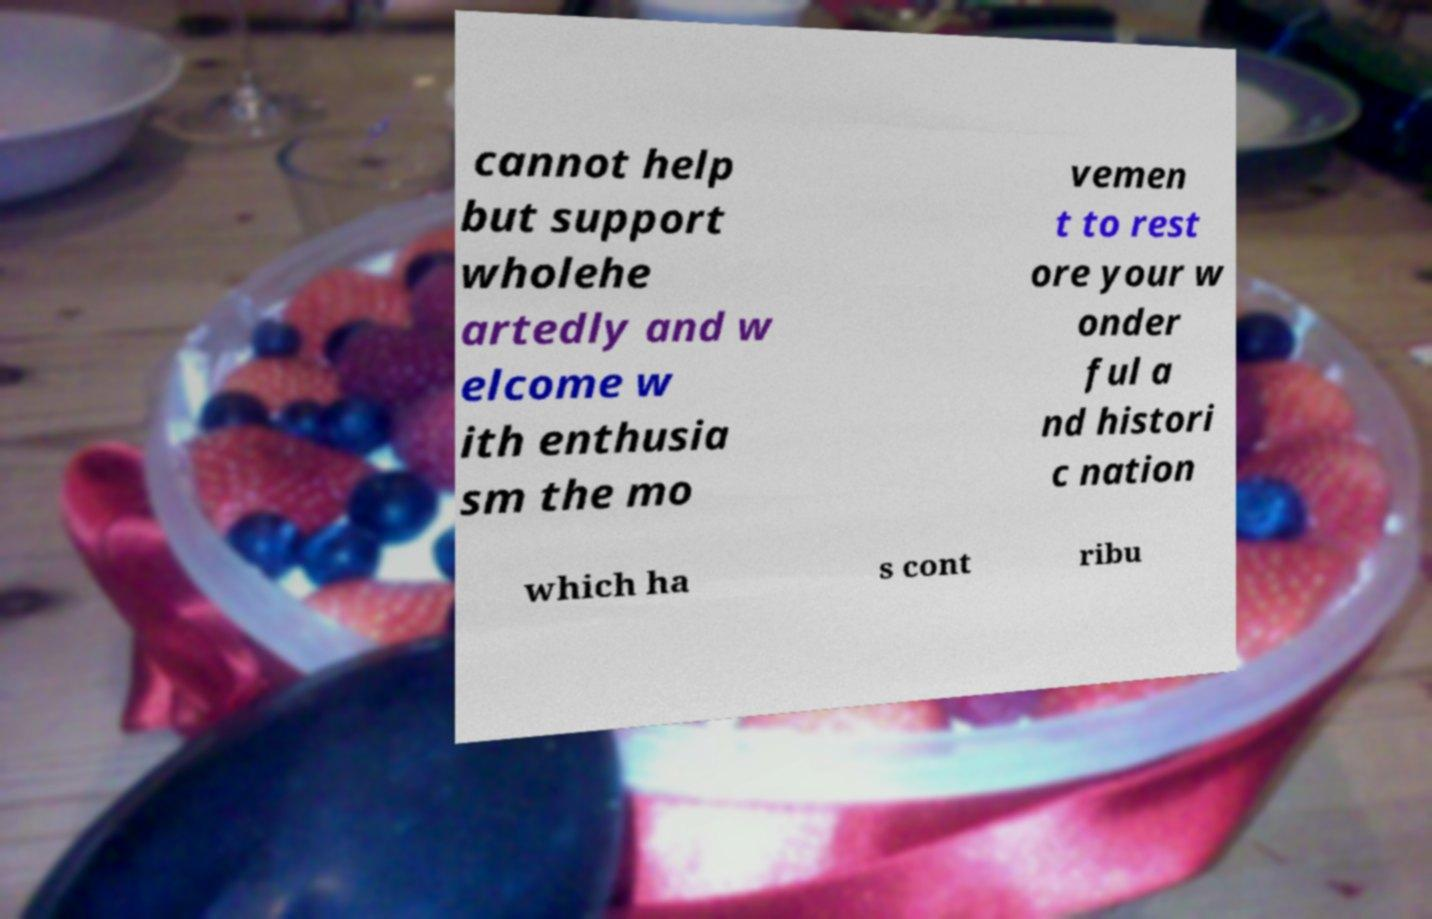For documentation purposes, I need the text within this image transcribed. Could you provide that? cannot help but support wholehe artedly and w elcome w ith enthusia sm the mo vemen t to rest ore your w onder ful a nd histori c nation which ha s cont ribu 